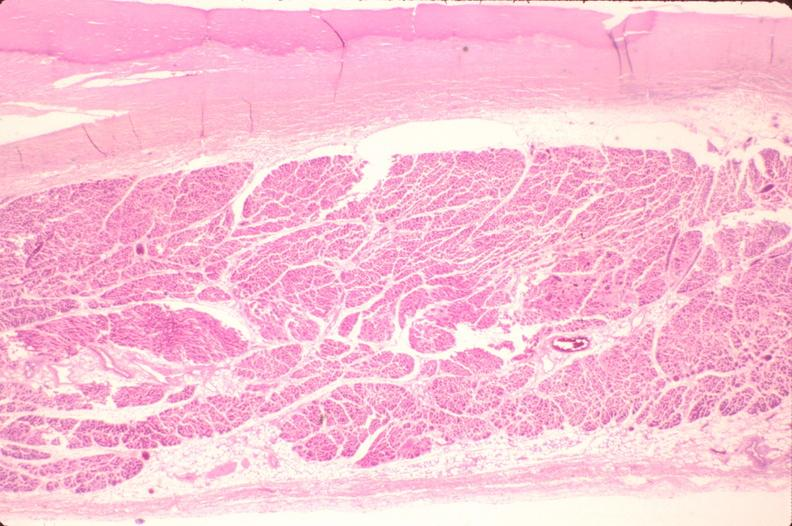s slide present?
Answer the question using a single word or phrase. No 